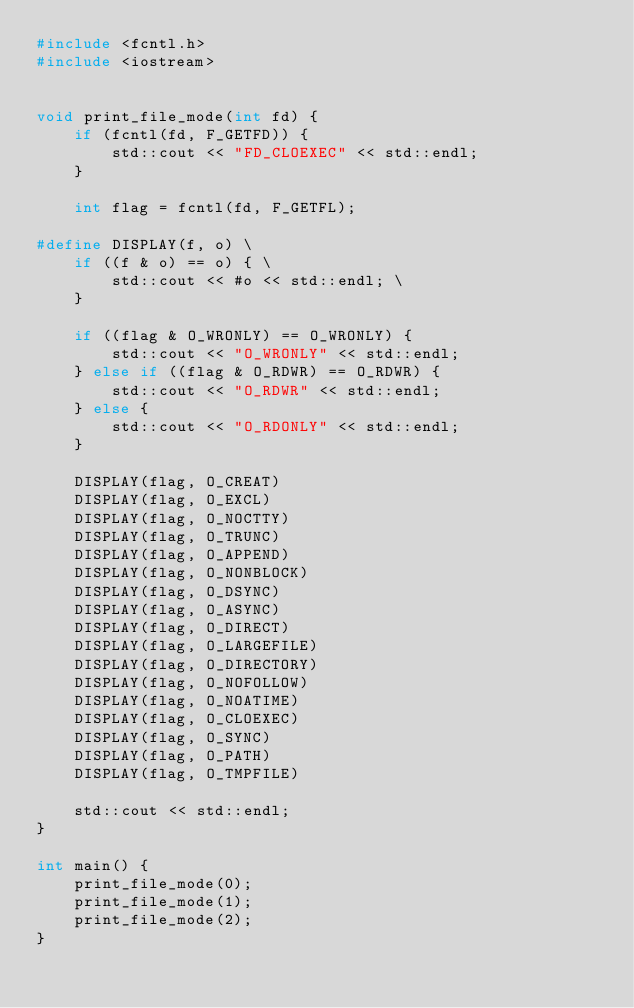<code> <loc_0><loc_0><loc_500><loc_500><_C++_>#include <fcntl.h>
#include <iostream>


void print_file_mode(int fd) {
    if (fcntl(fd, F_GETFD)) {
        std::cout << "FD_CLOEXEC" << std::endl;
    }

    int flag = fcntl(fd, F_GETFL);

#define DISPLAY(f, o) \
    if ((f & o) == o) { \
        std::cout << #o << std::endl; \
    }

    if ((flag & O_WRONLY) == O_WRONLY) {
        std::cout << "O_WRONLY" << std::endl;
    } else if ((flag & O_RDWR) == O_RDWR) {
        std::cout << "O_RDWR" << std::endl;
    } else {
        std::cout << "O_RDONLY" << std::endl;
    }

    DISPLAY(flag, O_CREAT)
    DISPLAY(flag, O_EXCL)
    DISPLAY(flag, O_NOCTTY)
    DISPLAY(flag, O_TRUNC)
    DISPLAY(flag, O_APPEND)
    DISPLAY(flag, O_NONBLOCK)
    DISPLAY(flag, O_DSYNC)
    DISPLAY(flag, O_ASYNC)
    DISPLAY(flag, O_DIRECT)
    DISPLAY(flag, O_LARGEFILE)
    DISPLAY(flag, O_DIRECTORY)
    DISPLAY(flag, O_NOFOLLOW)
    DISPLAY(flag, O_NOATIME)
    DISPLAY(flag, O_CLOEXEC)
    DISPLAY(flag, O_SYNC)
    DISPLAY(flag, O_PATH)
    DISPLAY(flag, O_TMPFILE)

    std::cout << std::endl;
}

int main() {
    print_file_mode(0);
    print_file_mode(1);
    print_file_mode(2);
}</code> 